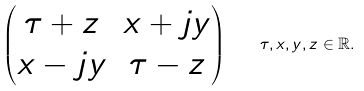<formula> <loc_0><loc_0><loc_500><loc_500>\begin{pmatrix} \tau + z & x + j y \\ x - j y & \tau - z \\ \end{pmatrix} \quad \tau , x , y , z \in \mathbb { R } .</formula> 